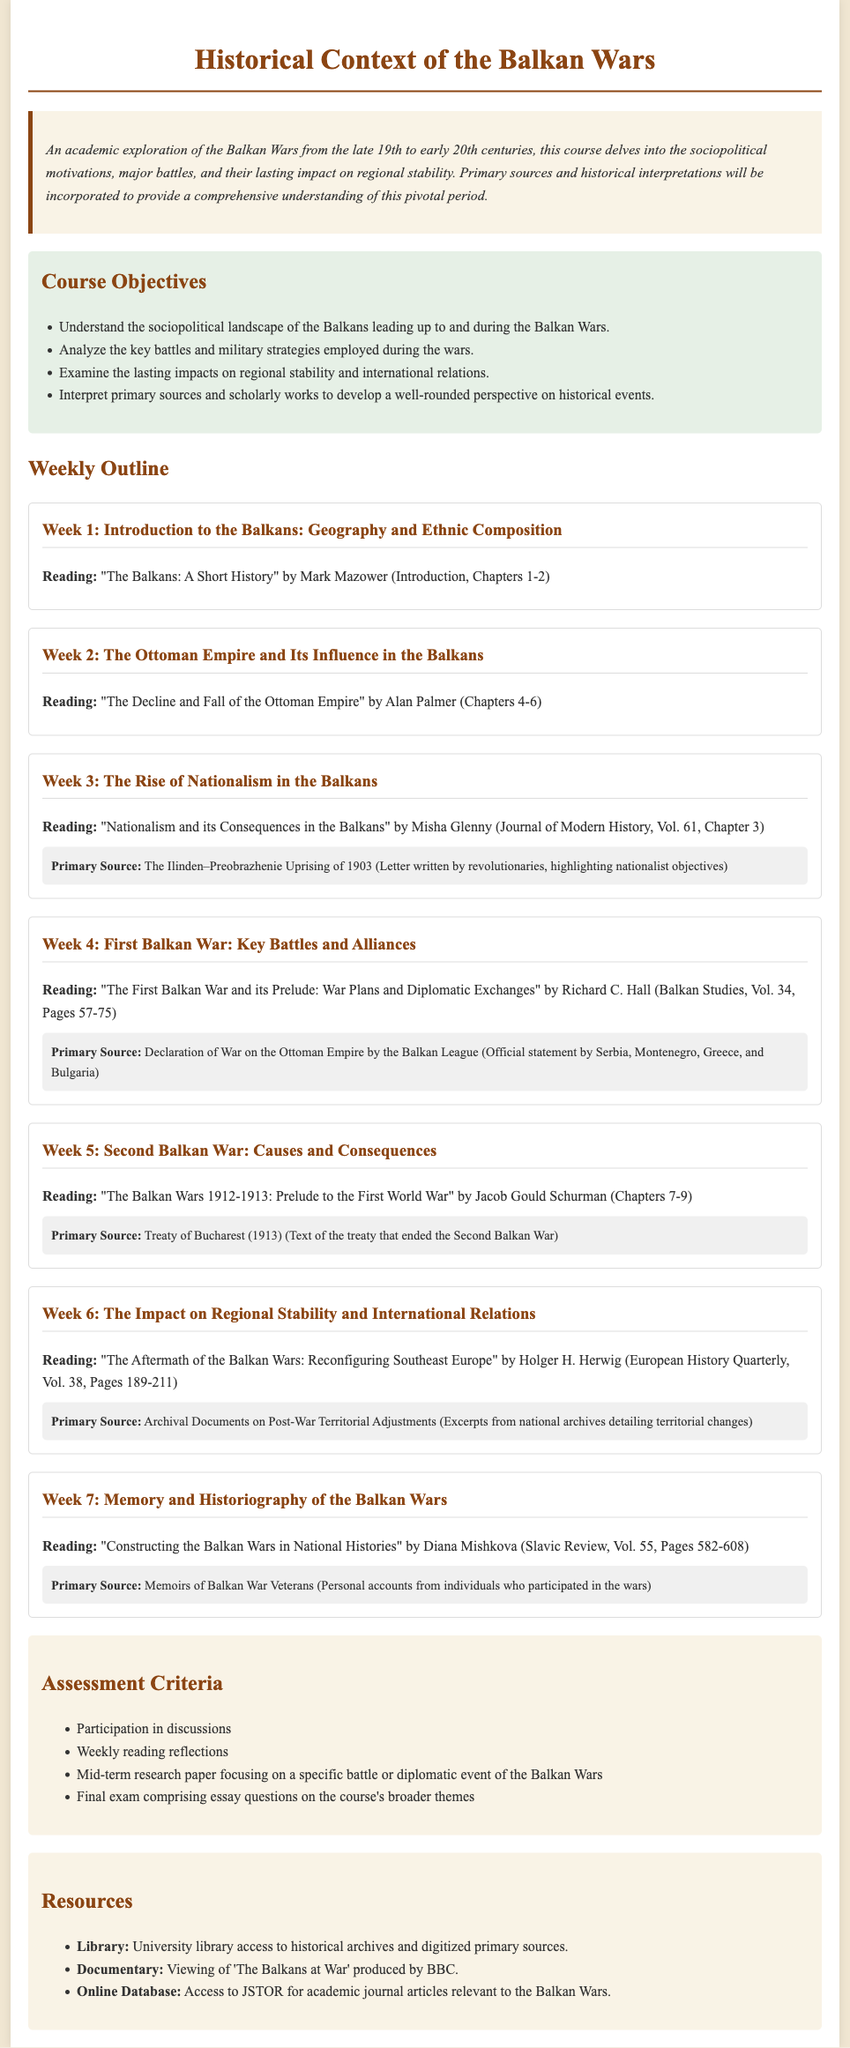What is the course title? The course title is the heading of the syllabus, listing the subject of study about the Balkan Wars.
Answer: Historical Context of the Balkan Wars Who is the author of the reading for Week 1? The name of the author for the reading assigned in Week 1 is specified directly in the syllabus text.
Answer: Mark Mazower What is one primary source used in Week 5? The syllabus lists specific primary sources associated with each weekly topic; Week 5 has one clearly mentioned.
Answer: Treaty of Bucharest How many weeks are dedicated to the course outline? The structure of the weekly outline is detailed in the document; counting the entries provides the answer.
Answer: 7 weeks What is one objective of the course? The objectives section specifies different aims for the course; one of them is listed explicitly.
Answer: Understand the sociopolitical landscape of the Balkans leading up to and during the Balkan Wars What type of document is this? The type of document is typically characterized by its content and structure, which includes learning objectives and readings.
Answer: Syllabus What is the focus of the mid-term assessment? The mid-term assessment focuses on a specific aspect, which is mentioned directly in the assessment criteria.
Answer: Research paper focusing on a specific battle or diplomatic event of the Balkan Wars 